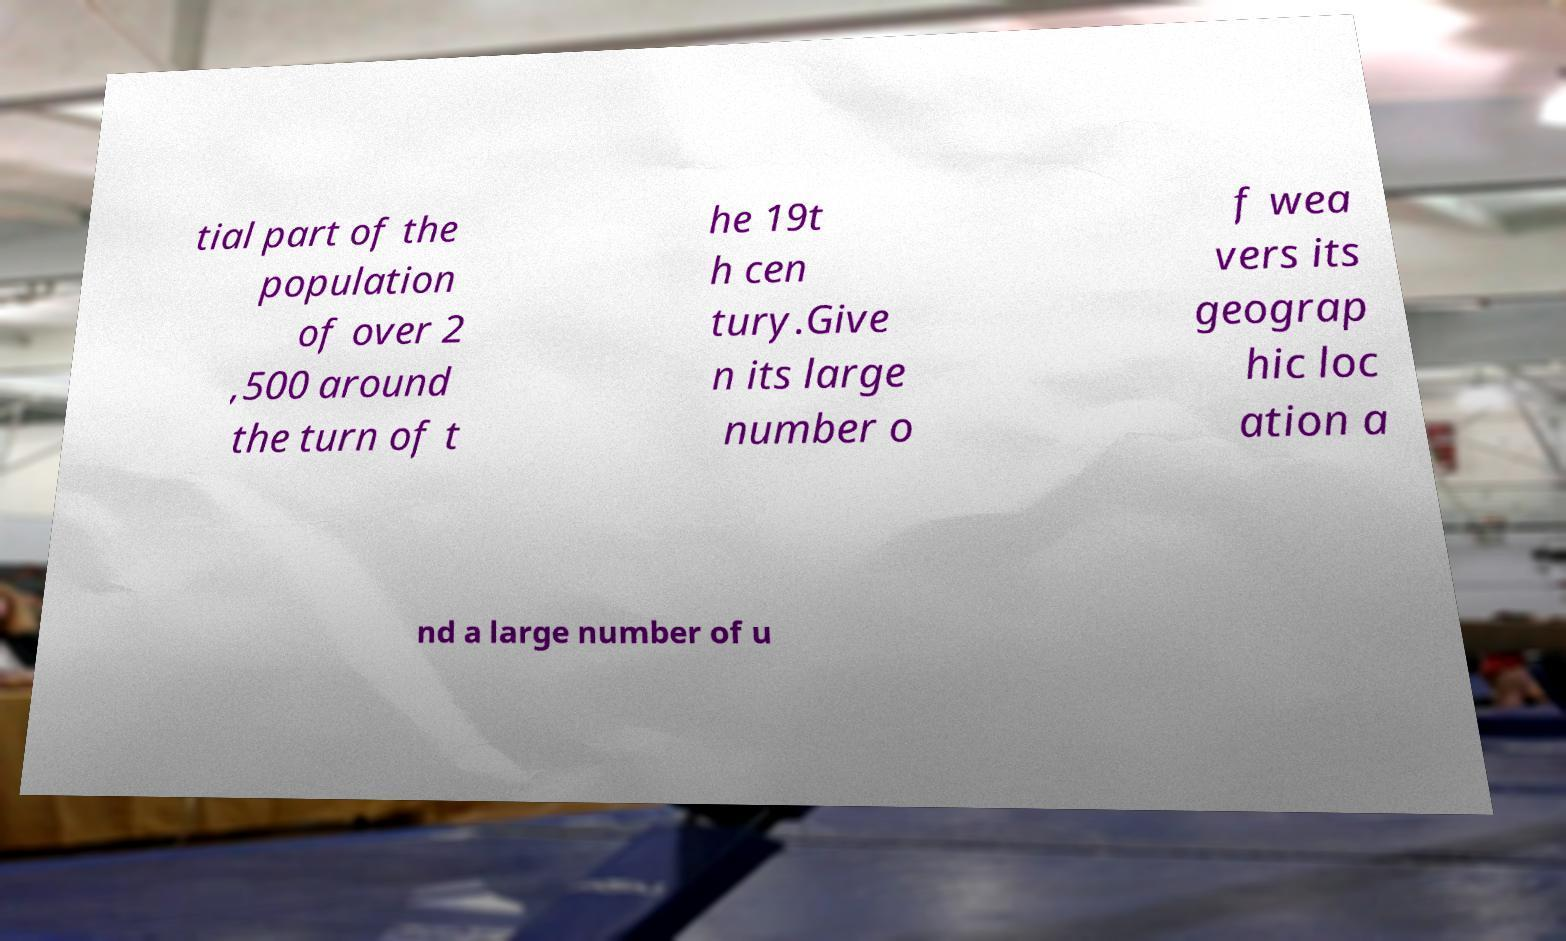What messages or text are displayed in this image? I need them in a readable, typed format. tial part of the population of over 2 ,500 around the turn of t he 19t h cen tury.Give n its large number o f wea vers its geograp hic loc ation a nd a large number of u 